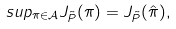Convert formula to latex. <formula><loc_0><loc_0><loc_500><loc_500>s u p _ { \pi \in \mathcal { A } } J _ { \tilde { P } } ( \pi ) = J _ { \tilde { P } } ( \hat { \pi } ) ,</formula> 